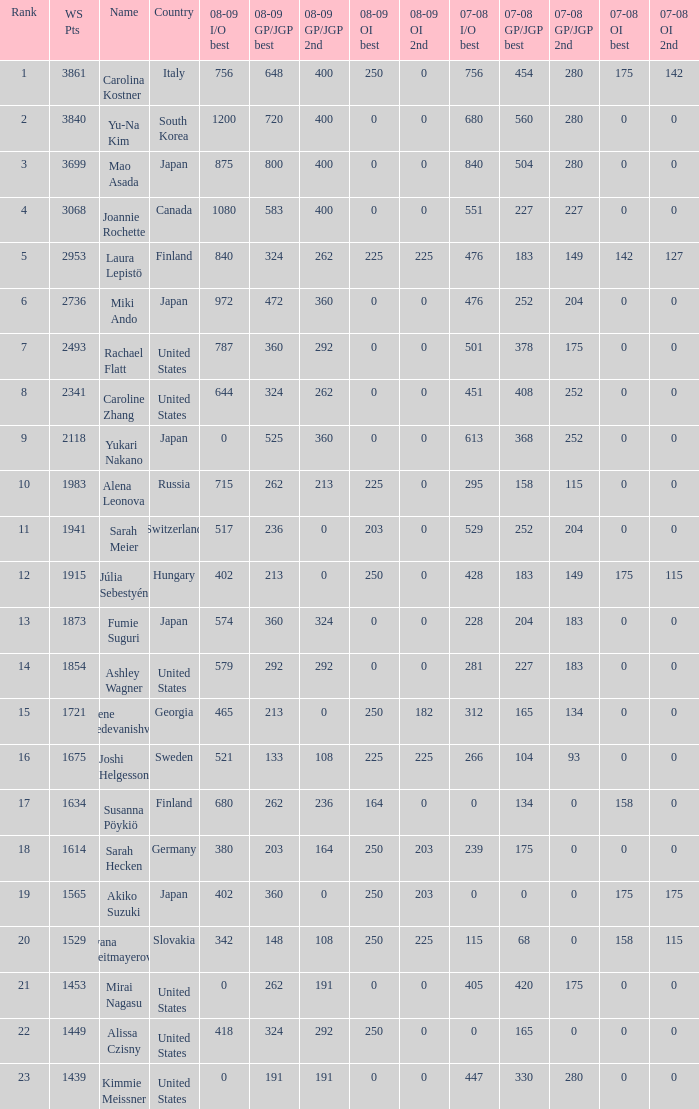Would you be able to parse every entry in this table? {'header': ['Rank', 'WS Pts', 'Name', 'Country', '08-09 I/O best', '08-09 GP/JGP best', '08-09 GP/JGP 2nd', '08-09 OI best', '08-09 OI 2nd', '07-08 I/O best', '07-08 GP/JGP best', '07-08 GP/JGP 2nd', '07-08 OI best', '07-08 OI 2nd'], 'rows': [['1', '3861', 'Carolina Kostner', 'Italy', '756', '648', '400', '250', '0', '756', '454', '280', '175', '142'], ['2', '3840', 'Yu-Na Kim', 'South Korea', '1200', '720', '400', '0', '0', '680', '560', '280', '0', '0'], ['3', '3699', 'Mao Asada', 'Japan', '875', '800', '400', '0', '0', '840', '504', '280', '0', '0'], ['4', '3068', 'Joannie Rochette', 'Canada', '1080', '583', '400', '0', '0', '551', '227', '227', '0', '0'], ['5', '2953', 'Laura Lepistö', 'Finland', '840', '324', '262', '225', '225', '476', '183', '149', '142', '127'], ['6', '2736', 'Miki Ando', 'Japan', '972', '472', '360', '0', '0', '476', '252', '204', '0', '0'], ['7', '2493', 'Rachael Flatt', 'United States', '787', '360', '292', '0', '0', '501', '378', '175', '0', '0'], ['8', '2341', 'Caroline Zhang', 'United States', '644', '324', '262', '0', '0', '451', '408', '252', '0', '0'], ['9', '2118', 'Yukari Nakano', 'Japan', '0', '525', '360', '0', '0', '613', '368', '252', '0', '0'], ['10', '1983', 'Alena Leonova', 'Russia', '715', '262', '213', '225', '0', '295', '158', '115', '0', '0'], ['11', '1941', 'Sarah Meier', 'Switzerland', '517', '236', '0', '203', '0', '529', '252', '204', '0', '0'], ['12', '1915', 'Júlia Sebestyén', 'Hungary', '402', '213', '0', '250', '0', '428', '183', '149', '175', '115'], ['13', '1873', 'Fumie Suguri', 'Japan', '574', '360', '324', '0', '0', '228', '204', '183', '0', '0'], ['14', '1854', 'Ashley Wagner', 'United States', '579', '292', '292', '0', '0', '281', '227', '183', '0', '0'], ['15', '1721', 'Elene Gedevanishvili', 'Georgia', '465', '213', '0', '250', '182', '312', '165', '134', '0', '0'], ['16', '1675', 'Joshi Helgesson', 'Sweden', '521', '133', '108', '225', '225', '266', '104', '93', '0', '0'], ['17', '1634', 'Susanna Pöykiö', 'Finland', '680', '262', '236', '164', '0', '0', '134', '0', '158', '0'], ['18', '1614', 'Sarah Hecken', 'Germany', '380', '203', '164', '250', '203', '239', '175', '0', '0', '0'], ['19', '1565', 'Akiko Suzuki', 'Japan', '402', '360', '0', '250', '203', '0', '0', '0', '175', '175'], ['20', '1529', 'Ivana Reitmayerova', 'Slovakia', '342', '148', '108', '250', '225', '115', '68', '0', '158', '115'], ['21', '1453', 'Mirai Nagasu', 'United States', '0', '262', '191', '0', '0', '405', '420', '175', '0', '0'], ['22', '1449', 'Alissa Czisny', 'United States', '418', '324', '292', '250', '0', '0', '165', '0', '0', '0'], ['23', '1439', 'Kimmie Meissner', 'United States', '0', '191', '191', '0', '0', '447', '330', '280', '0', '0']]} 08-09 gp/jgp 2nd is 213 and ws points will be what maximum 1983.0. 